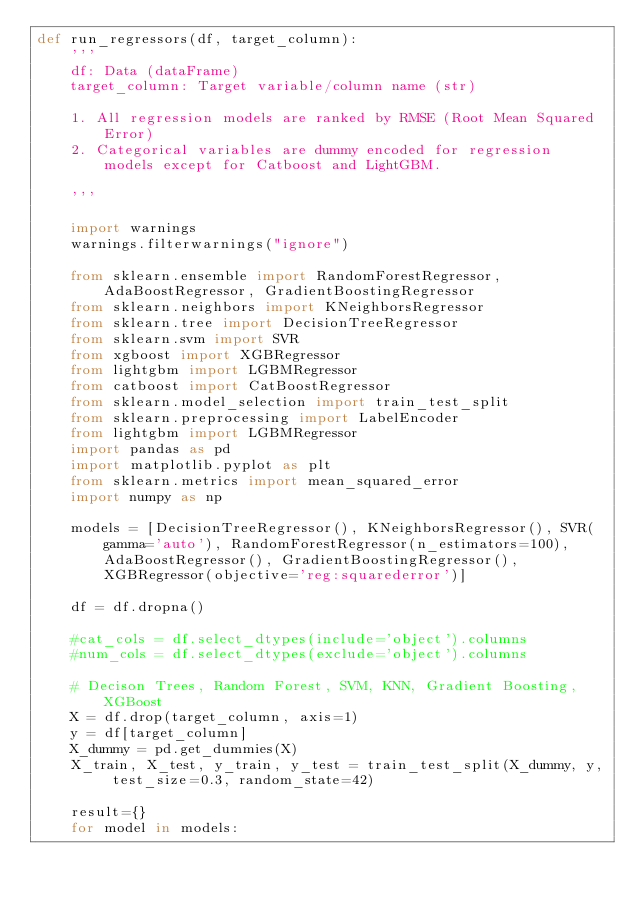<code> <loc_0><loc_0><loc_500><loc_500><_Python_>def run_regressors(df, target_column):
    '''
    df: Data (dataFrame)
    target_column: Target variable/column name (str)

    1. All regression models are ranked by RMSE (Root Mean Squared Error)
    2. Categorical variables are dummy encoded for regression models except for Catboost and LightGBM.

    '''

    import warnings
    warnings.filterwarnings("ignore")

    from sklearn.ensemble import RandomForestRegressor, AdaBoostRegressor, GradientBoostingRegressor
    from sklearn.neighbors import KNeighborsRegressor
    from sklearn.tree import DecisionTreeRegressor
    from sklearn.svm import SVR
    from xgboost import XGBRegressor
    from lightgbm import LGBMRegressor
    from catboost import CatBoostRegressor
    from sklearn.model_selection import train_test_split
    from sklearn.preprocessing import LabelEncoder
    from lightgbm import LGBMRegressor
    import pandas as pd
    import matplotlib.pyplot as plt
    from sklearn.metrics import mean_squared_error
    import numpy as np

    models = [DecisionTreeRegressor(), KNeighborsRegressor(), SVR(gamma='auto'), RandomForestRegressor(n_estimators=100), AdaBoostRegressor(), GradientBoostingRegressor(), XGBRegressor(objective='reg:squarederror')]

    df = df.dropna()

    #cat_cols = df.select_dtypes(include='object').columns
    #num_cols = df.select_dtypes(exclude='object').columns

    # Decison Trees, Random Forest, SVM, KNN, Gradient Boosting, XGBoost
    X = df.drop(target_column, axis=1)
    y = df[target_column]
    X_dummy = pd.get_dummies(X)
    X_train, X_test, y_train, y_test = train_test_split(X_dummy, y, test_size=0.3, random_state=42)

    result={}
    for model in models:</code> 